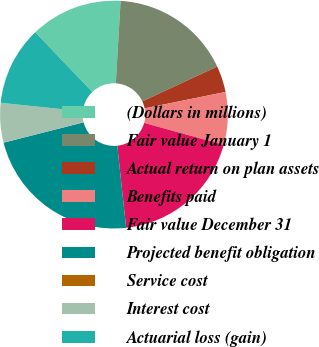Convert chart. <chart><loc_0><loc_0><loc_500><loc_500><pie_chart><fcel>(Dollars in millions)<fcel>Fair value January 1<fcel>Actual return on plan assets<fcel>Benefits paid<fcel>Fair value December 31<fcel>Projected benefit obligation<fcel>Service cost<fcel>Interest cost<fcel>Actuarial loss (gain)<nl><fcel>13.07%<fcel>17.14%<fcel>3.74%<fcel>7.47%<fcel>19.01%<fcel>22.74%<fcel>0.01%<fcel>5.61%<fcel>11.21%<nl></chart> 